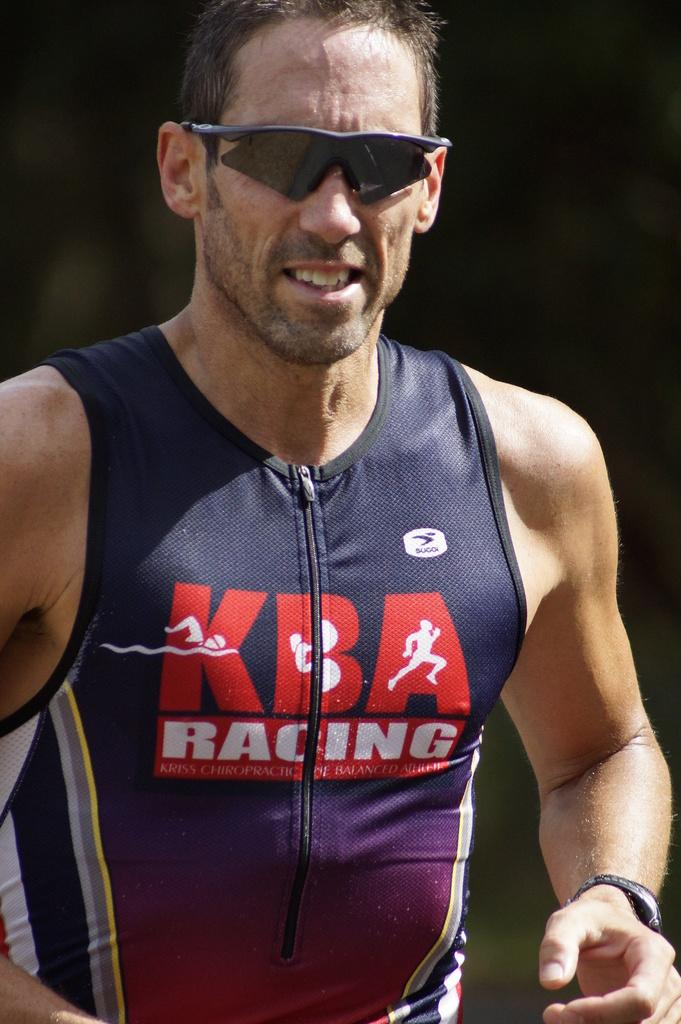<image>
Share a concise interpretation of the image provided. A runner wearing a shirt that states KBA Racing. 